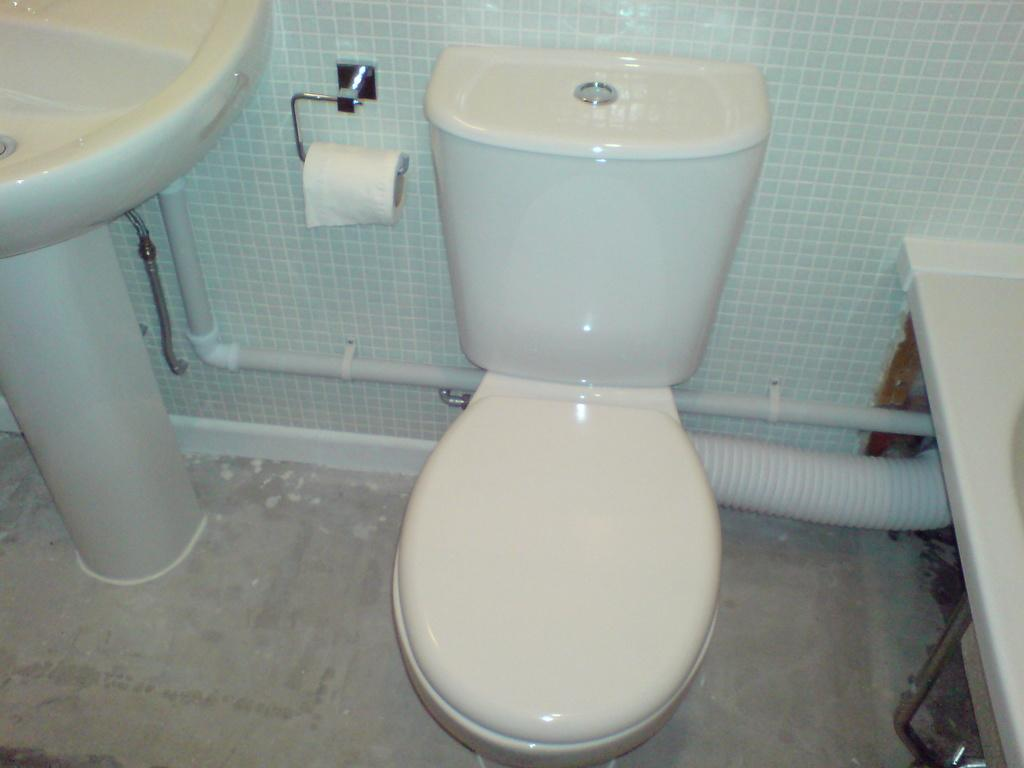What type of fixture is present in the image? There is a washbasin in the image. What can be seen connected to the washbasin? Pipes are visible in the image. What item is commonly used for personal hygiene and is present in the image? There is toilet paper in the image. What type of toilet is depicted in the image? There is a western toilet in the image. What material is the wall made of in the image? The wall in the image is made of marble. How many passengers are waiting in line for the rice in the image? There is no reference to passengers or rice in the image; it features a washbasin, pipes, toilet paper, a western toilet, and a marble wall. 